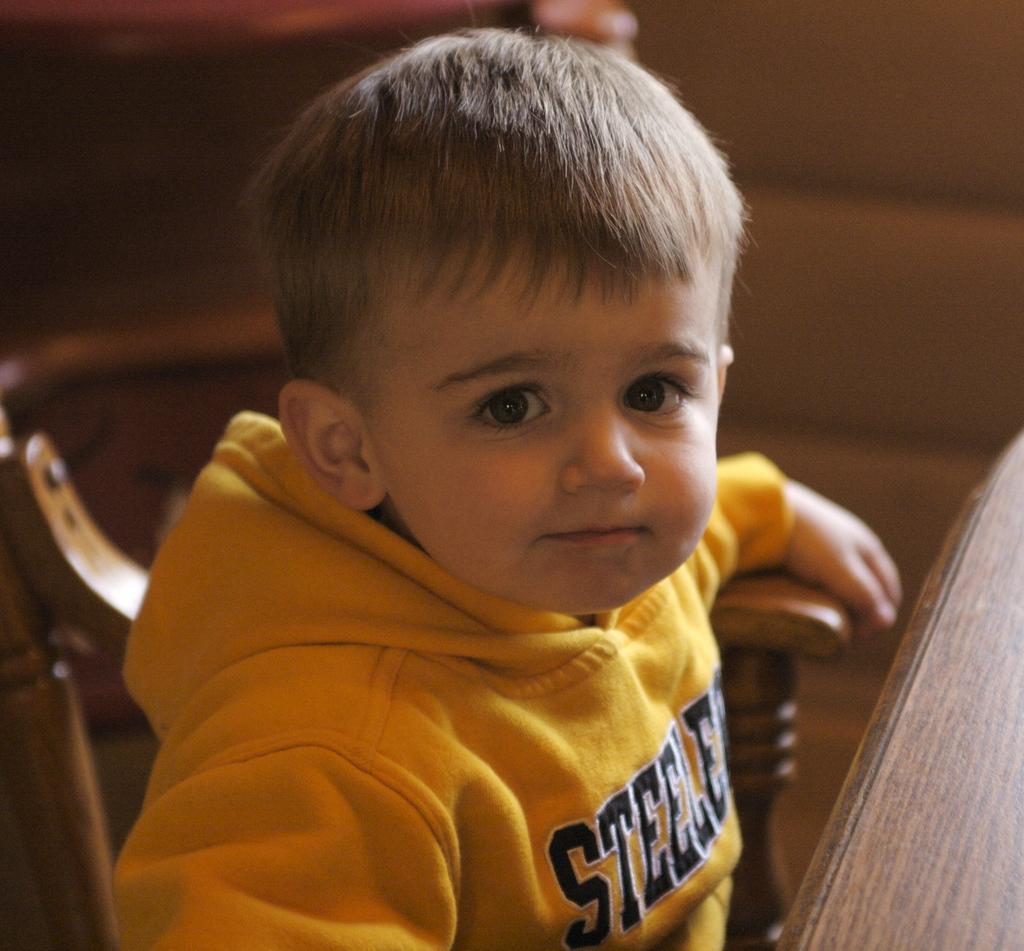In one or two sentences, can you explain what this image depicts? In this image a kid wearing a yellow jacket is sitting on the chair. Before him there is a table. 